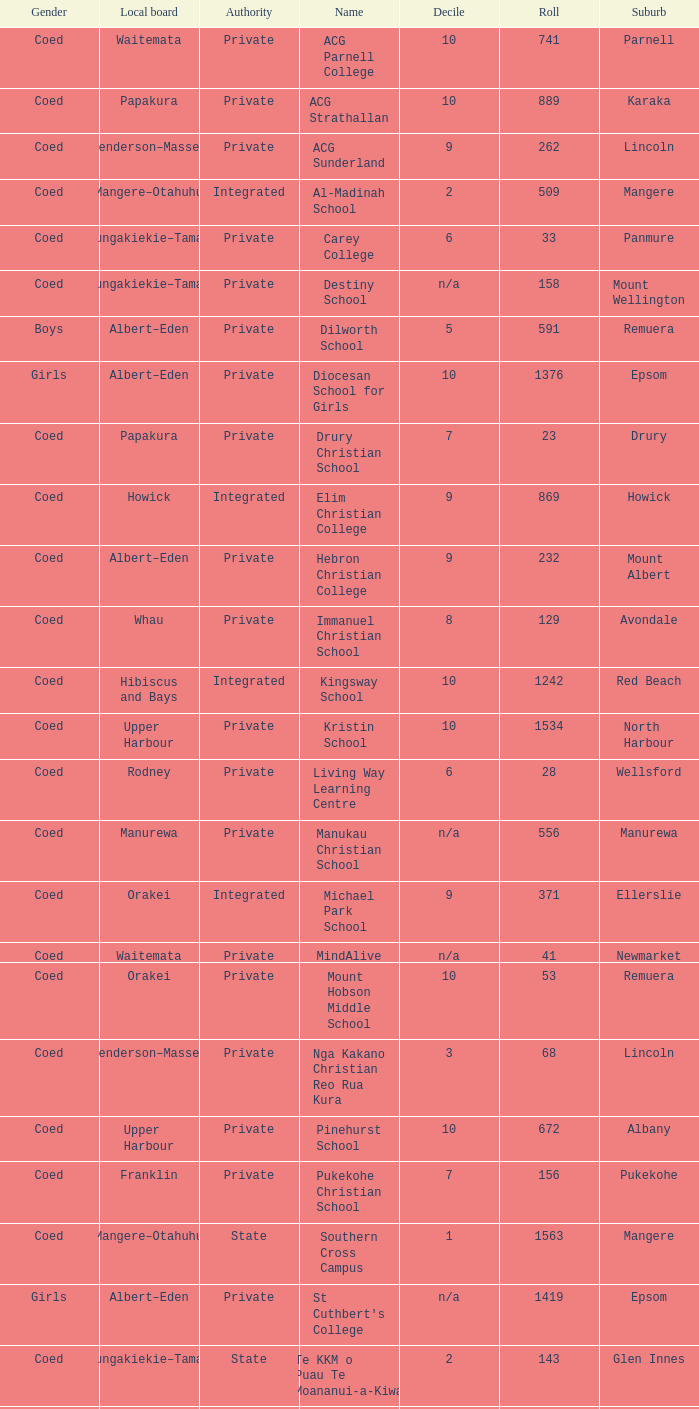What is the name of the suburb with a roll of 741? Parnell. 